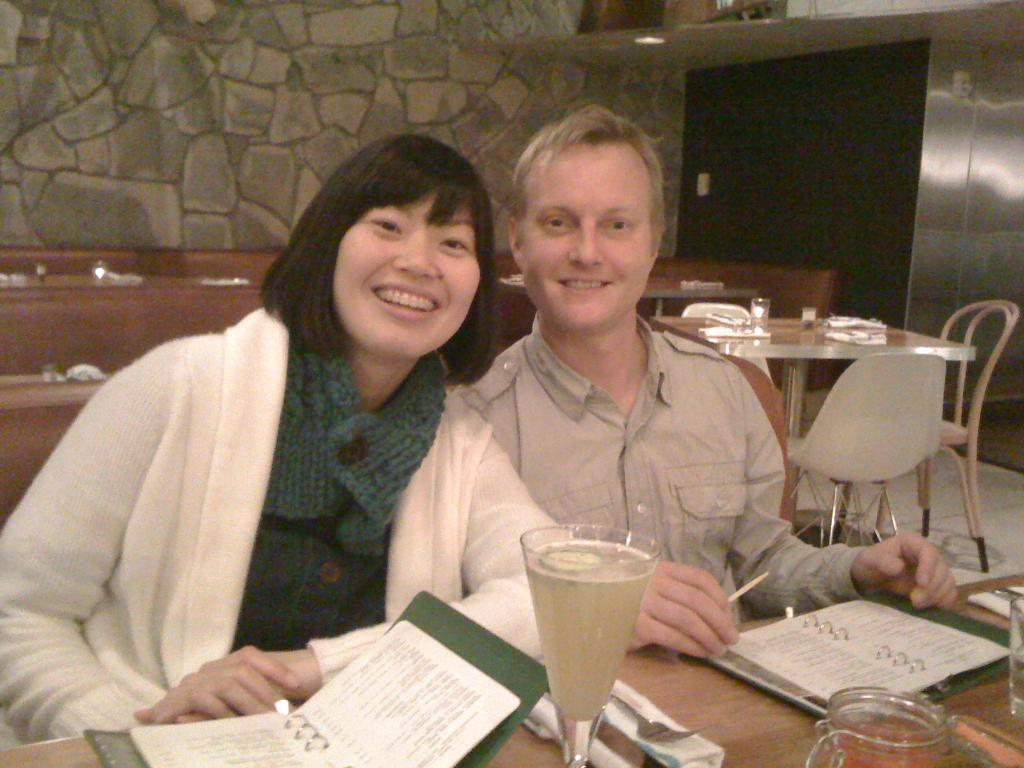How many people are in the image? There are two people in the image. What is the lady doing in the image? The lady is smiling in the image. How is the man positioned in relation to the lady? The man is sitting beside the lady in the image. What type of list can be seen in the hands of the lady in the image? There is no list present in the image; the lady is simply smiling. How many pigs are visible in the image? There are no pigs present in the image. 